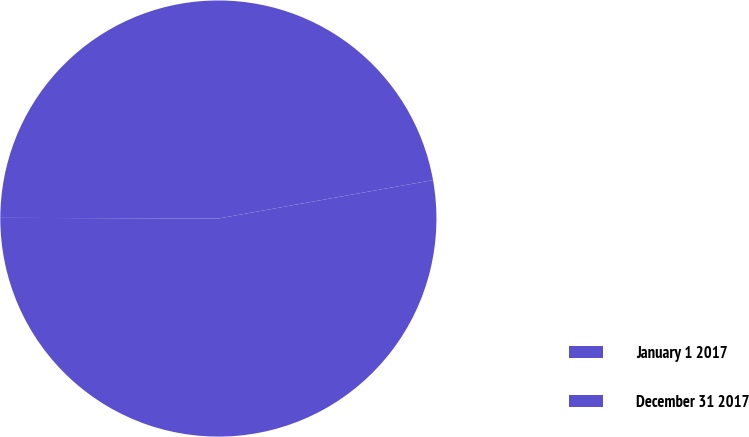Convert chart. <chart><loc_0><loc_0><loc_500><loc_500><pie_chart><fcel>January 1 2017<fcel>December 31 2017<nl><fcel>52.87%<fcel>47.13%<nl></chart> 